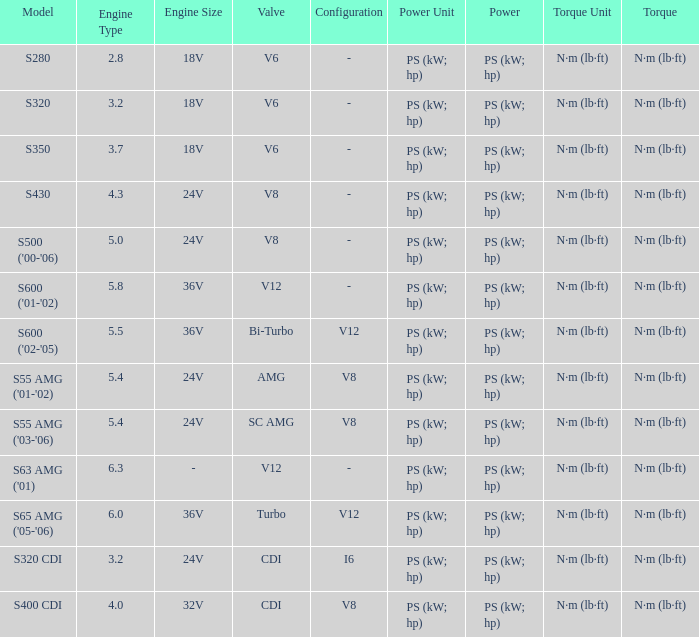Which Engine has a Model of s430? 4.3 24V. 